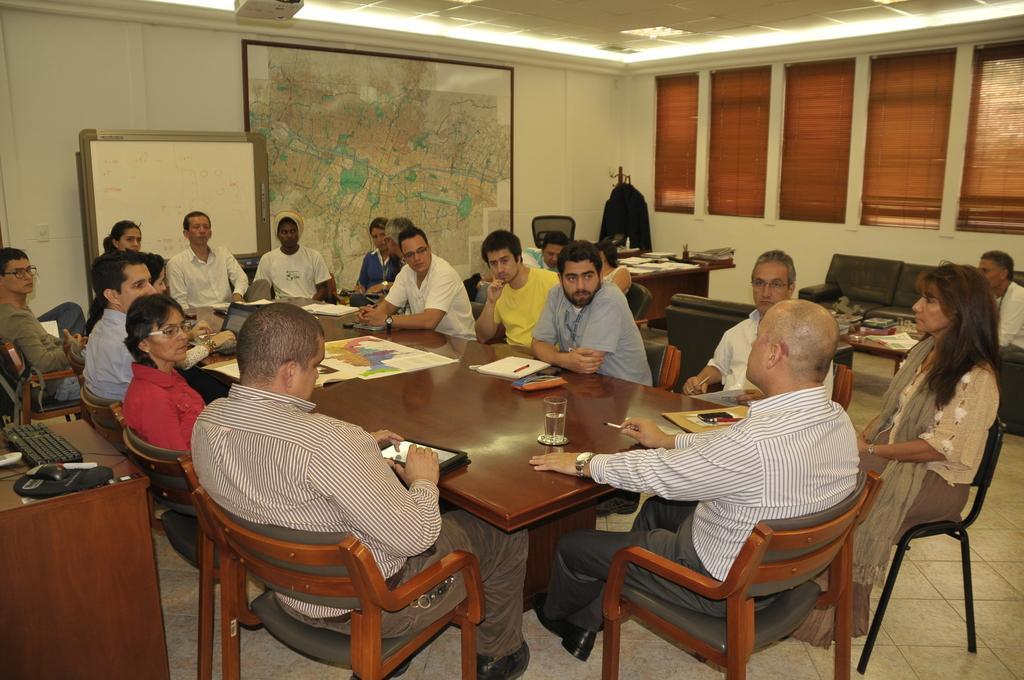How would you summarize this image in a sentence or two? In this picture we can see some persons sitting on the chairs. This is table, on the table there is a glass, book, and a paper. And there is a laptop. This is the sofa. On the background we can see the wall. There is a frame on the wall. This is the light. And here we can see a keyboard and a mouse on the table. And this is the floor. 